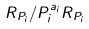<formula> <loc_0><loc_0><loc_500><loc_500>R _ { P _ { i } } / P _ { i } ^ { a _ { i } } R _ { P _ { i } }</formula> 